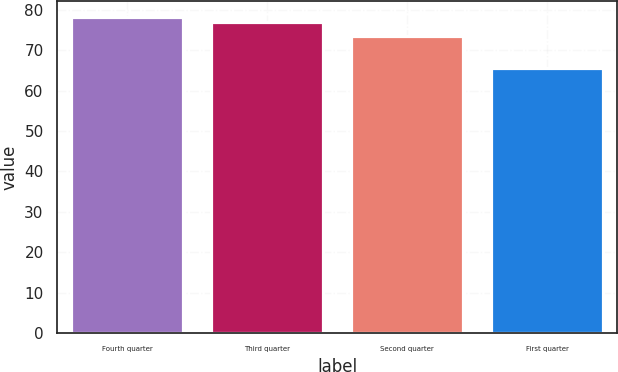<chart> <loc_0><loc_0><loc_500><loc_500><bar_chart><fcel>Fourth quarter<fcel>Third quarter<fcel>Second quarter<fcel>First quarter<nl><fcel>78.17<fcel>76.92<fcel>73.57<fcel>65.48<nl></chart> 